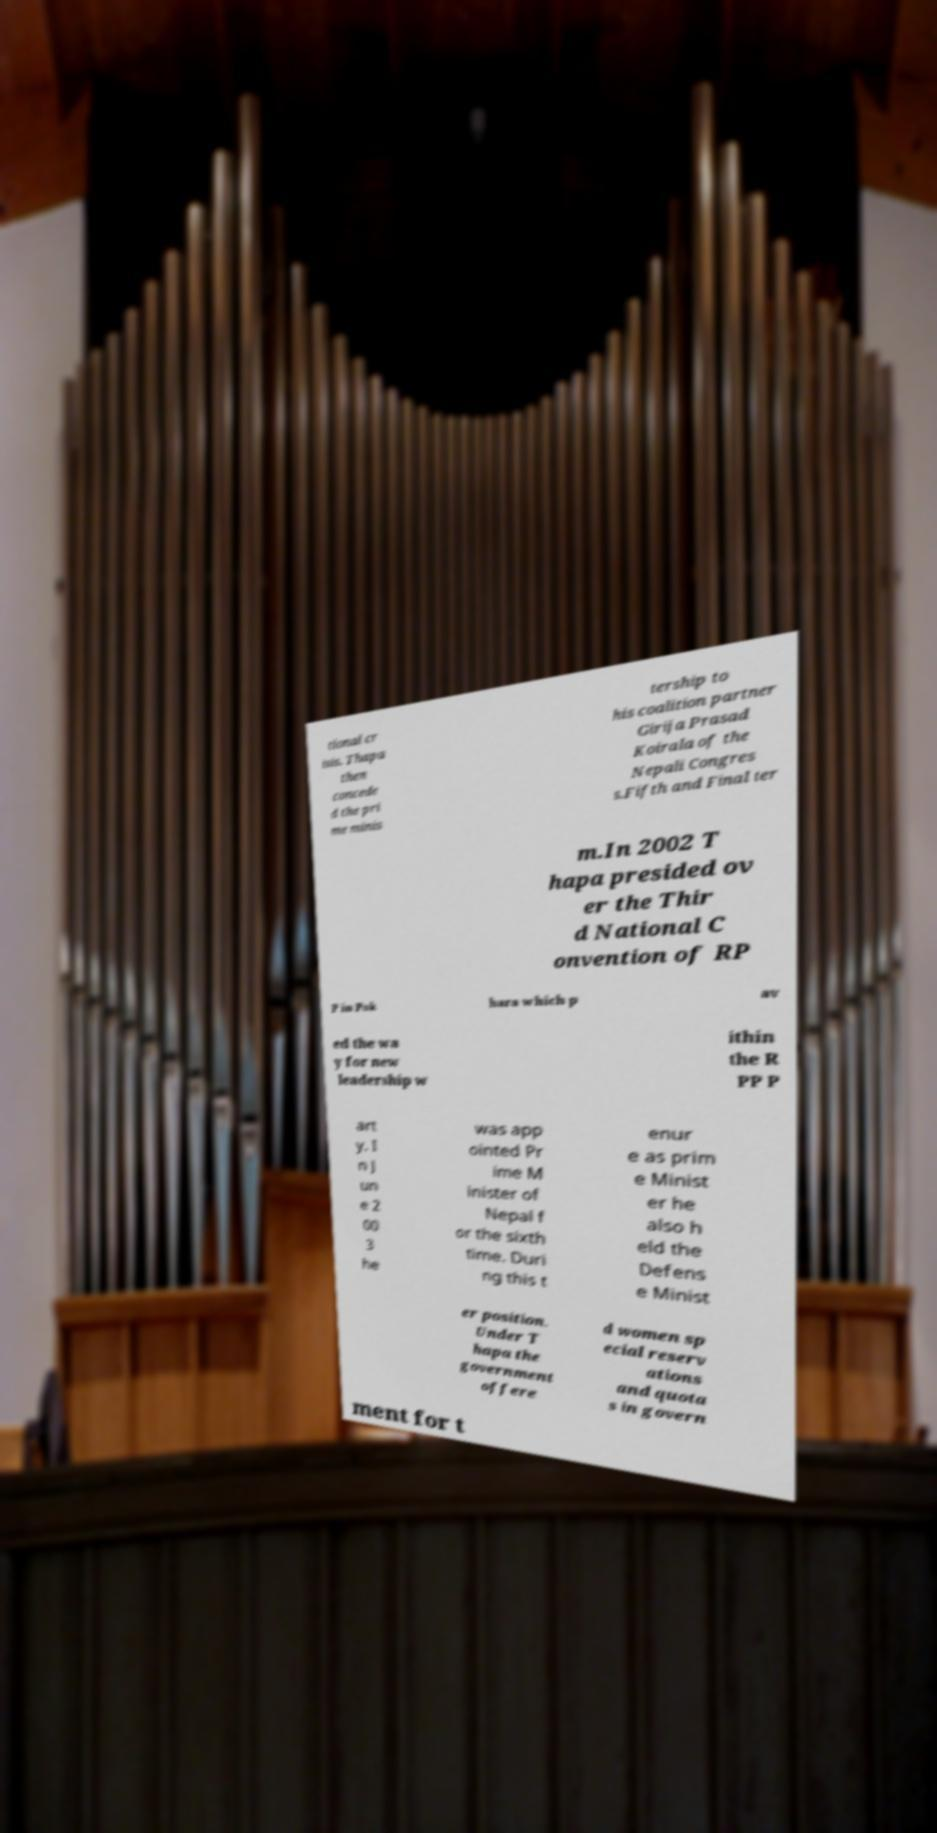What messages or text are displayed in this image? I need them in a readable, typed format. tional cr isis. Thapa then concede d the pri me minis tership to his coalition partner Girija Prasad Koirala of the Nepali Congres s.Fifth and Final ter m.In 2002 T hapa presided ov er the Thir d National C onvention of RP P in Pok hara which p av ed the wa y for new leadership w ithin the R PP P art y. I n J un e 2 00 3 he was app ointed Pr ime M inister of Nepal f or the sixth time. Duri ng this t enur e as prim e Minist er he also h eld the Defens e Minist er position. Under T hapa the government offere d women sp ecial reserv ations and quota s in govern ment for t 